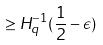Convert formula to latex. <formula><loc_0><loc_0><loc_500><loc_500>\geq H _ { q } ^ { - 1 } ( \frac { 1 } { 2 } - \epsilon )</formula> 